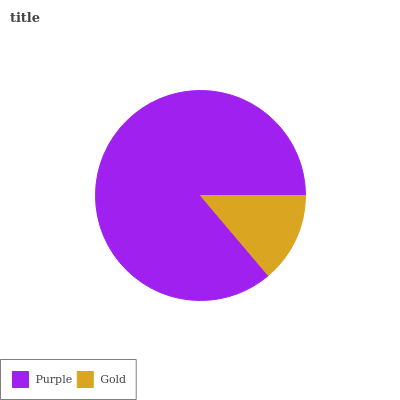Is Gold the minimum?
Answer yes or no. Yes. Is Purple the maximum?
Answer yes or no. Yes. Is Gold the maximum?
Answer yes or no. No. Is Purple greater than Gold?
Answer yes or no. Yes. Is Gold less than Purple?
Answer yes or no. Yes. Is Gold greater than Purple?
Answer yes or no. No. Is Purple less than Gold?
Answer yes or no. No. Is Purple the high median?
Answer yes or no. Yes. Is Gold the low median?
Answer yes or no. Yes. Is Gold the high median?
Answer yes or no. No. Is Purple the low median?
Answer yes or no. No. 